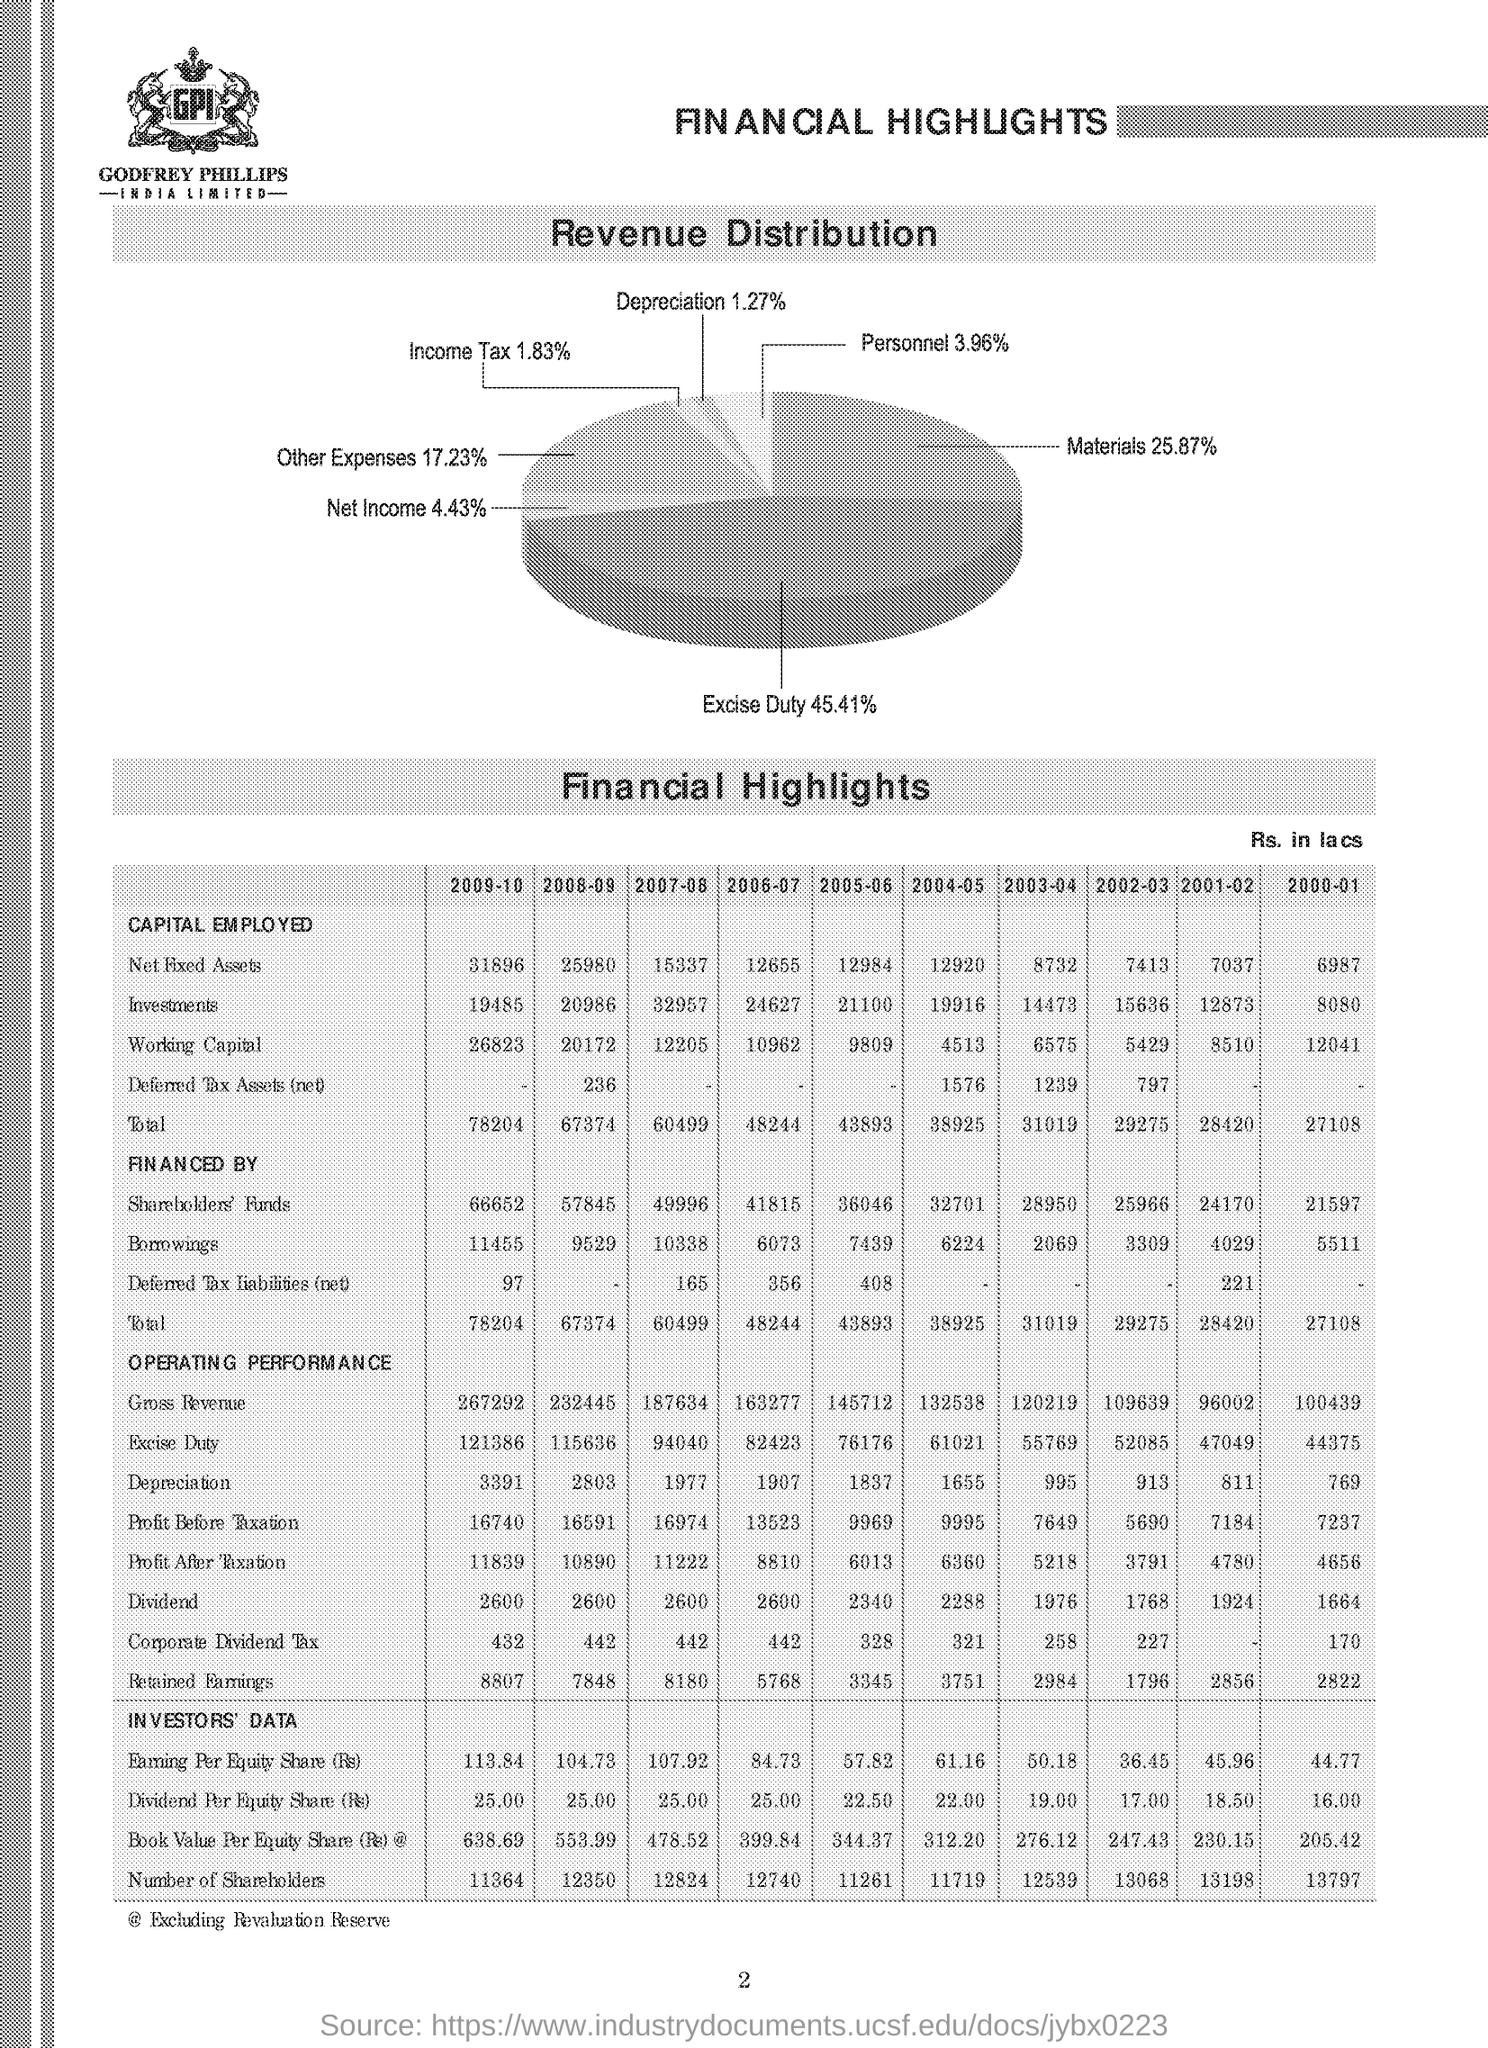Identify some key points in this picture. The excise duty as a percentage of revenue is 45.41. In terms of revenue distribution, materials account for 25.87%. The depreciation as a percentage of revenue in the distribution is 1.27. The income tax rate in the revenue distribution is 1.83%. The total capital employed for the year 2009-2010 was 78,204. 